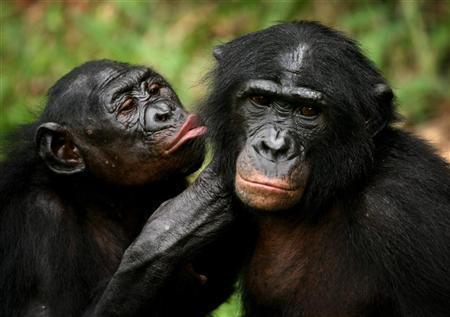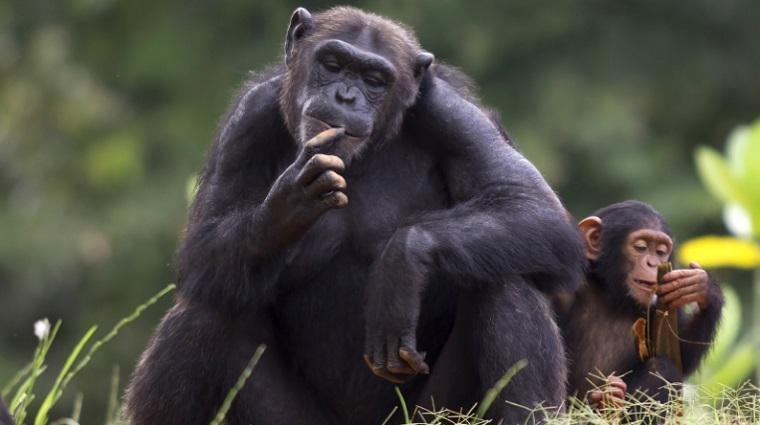The first image is the image on the left, the second image is the image on the right. Examine the images to the left and right. Is the description "The animal in the image on the left has its back to a tree." accurate? Answer yes or no. No. The first image is the image on the left, the second image is the image on the right. Considering the images on both sides, is "The left image features exactly one chimpanzee." valid? Answer yes or no. No. 